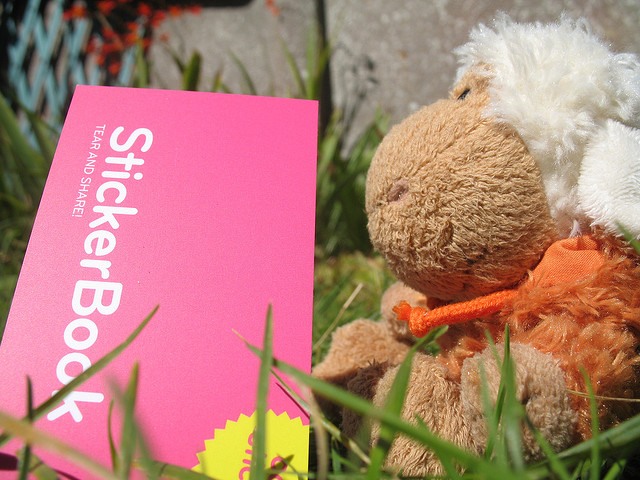<image>What holiday are these gifts for? I am not sure what holiday these gifts are for. They could be for Easter, Christmas, or a birthday. What holiday are these gifts for? I don't know what holiday these gifts are for. It can be Easter, Christmas, or a birthday. 